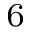<formula> <loc_0><loc_0><loc_500><loc_500>^ { 6 }</formula> 